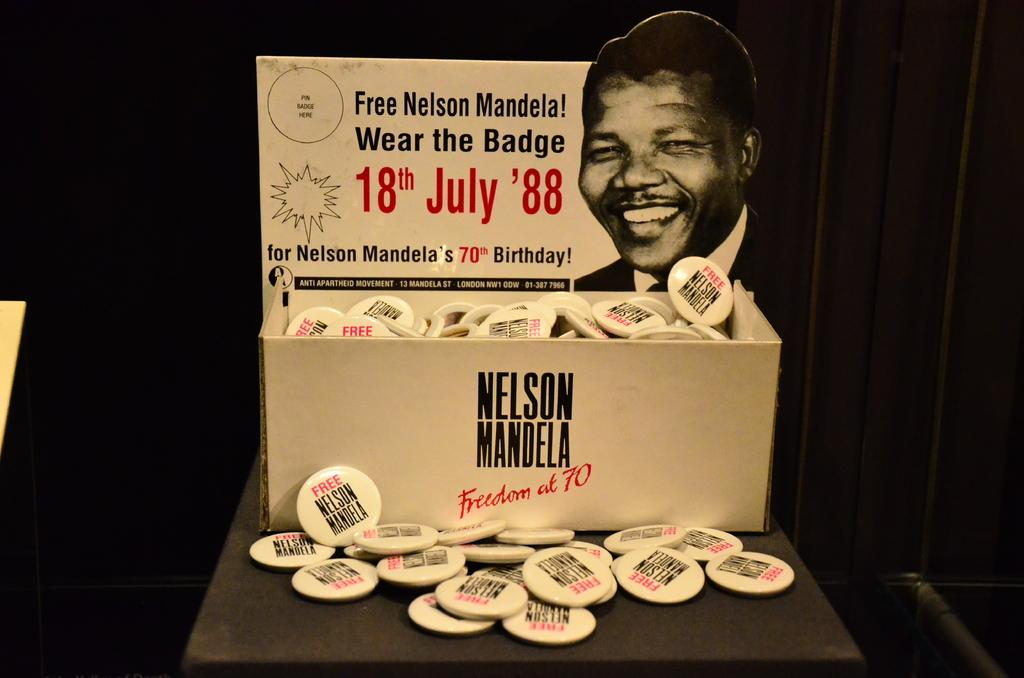What is depicted on the badges in the image? The badges in the image feature Nelson Mandela. How are the badges stored in the image? The badges are kept in a box. What color is the background of the box? The background of the box is black. How many kittens can be seen reading books in the image? There are no kittens or books present in the image; it features badges of Nelson Mandela in a black-backgrounded box. 